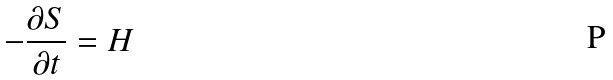Convert formula to latex. <formula><loc_0><loc_0><loc_500><loc_500>- \frac { \partial S } { \partial t } = H</formula> 